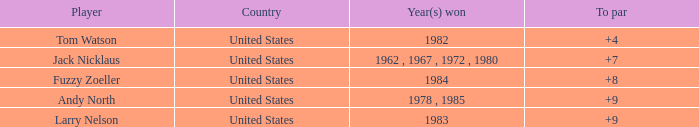For andy north, what is his to par when the total is more than 153? 0.0. 